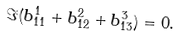Convert formula to latex. <formula><loc_0><loc_0><loc_500><loc_500>\Im ( b _ { 1 1 } ^ { 1 } + b _ { 1 2 } ^ { 2 } + b _ { 1 3 } ^ { 3 } ) = 0 .</formula> 